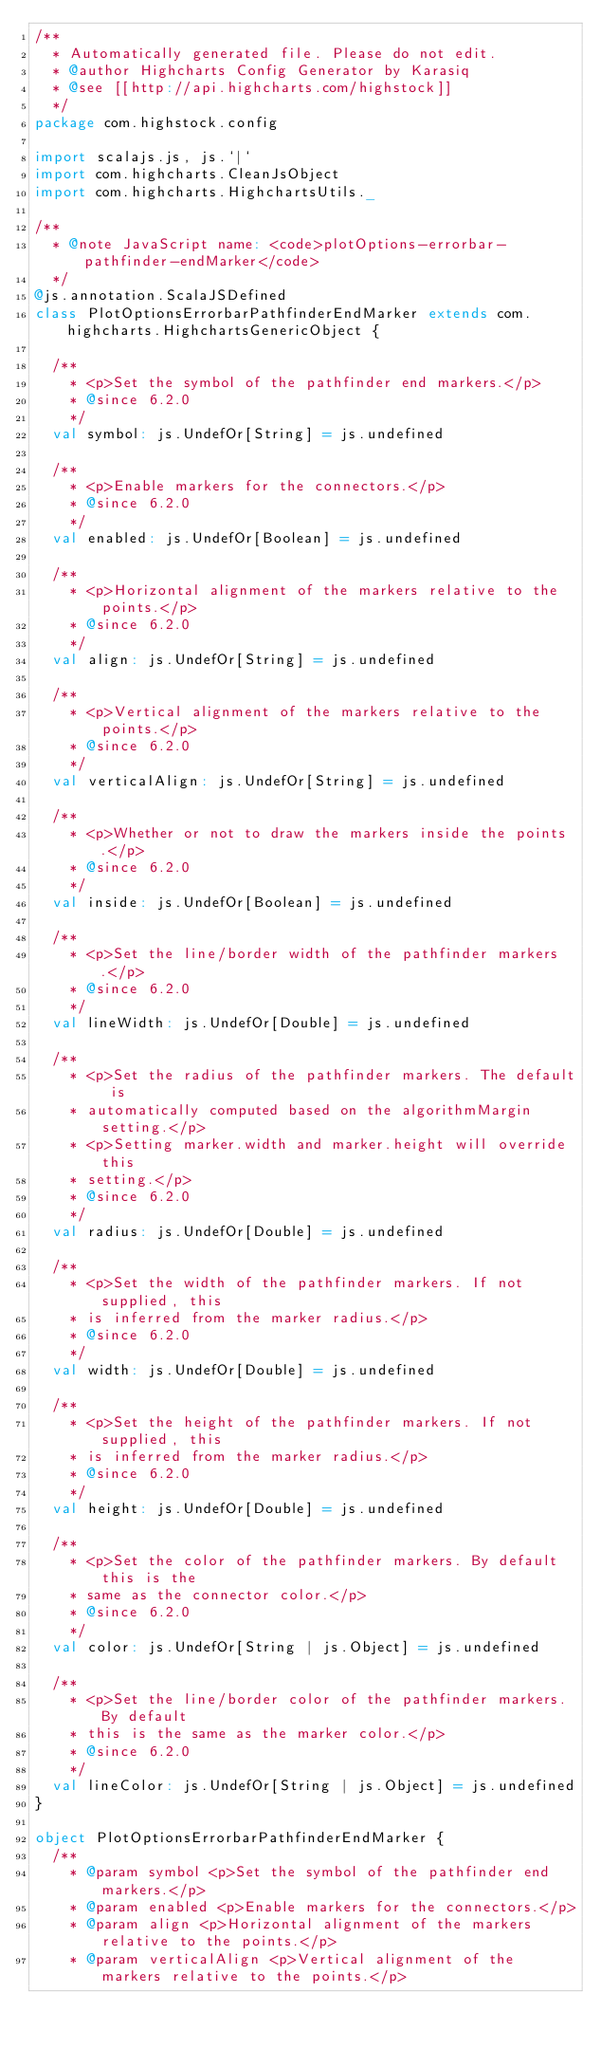Convert code to text. <code><loc_0><loc_0><loc_500><loc_500><_Scala_>/**
  * Automatically generated file. Please do not edit.
  * @author Highcharts Config Generator by Karasiq
  * @see [[http://api.highcharts.com/highstock]]
  */
package com.highstock.config

import scalajs.js, js.`|`
import com.highcharts.CleanJsObject
import com.highcharts.HighchartsUtils._

/**
  * @note JavaScript name: <code>plotOptions-errorbar-pathfinder-endMarker</code>
  */
@js.annotation.ScalaJSDefined
class PlotOptionsErrorbarPathfinderEndMarker extends com.highcharts.HighchartsGenericObject {

  /**
    * <p>Set the symbol of the pathfinder end markers.</p>
    * @since 6.2.0
    */
  val symbol: js.UndefOr[String] = js.undefined

  /**
    * <p>Enable markers for the connectors.</p>
    * @since 6.2.0
    */
  val enabled: js.UndefOr[Boolean] = js.undefined

  /**
    * <p>Horizontal alignment of the markers relative to the points.</p>
    * @since 6.2.0
    */
  val align: js.UndefOr[String] = js.undefined

  /**
    * <p>Vertical alignment of the markers relative to the points.</p>
    * @since 6.2.0
    */
  val verticalAlign: js.UndefOr[String] = js.undefined

  /**
    * <p>Whether or not to draw the markers inside the points.</p>
    * @since 6.2.0
    */
  val inside: js.UndefOr[Boolean] = js.undefined

  /**
    * <p>Set the line/border width of the pathfinder markers.</p>
    * @since 6.2.0
    */
  val lineWidth: js.UndefOr[Double] = js.undefined

  /**
    * <p>Set the radius of the pathfinder markers. The default is
    * automatically computed based on the algorithmMargin setting.</p>
    * <p>Setting marker.width and marker.height will override this
    * setting.</p>
    * @since 6.2.0
    */
  val radius: js.UndefOr[Double] = js.undefined

  /**
    * <p>Set the width of the pathfinder markers. If not supplied, this
    * is inferred from the marker radius.</p>
    * @since 6.2.0
    */
  val width: js.UndefOr[Double] = js.undefined

  /**
    * <p>Set the height of the pathfinder markers. If not supplied, this
    * is inferred from the marker radius.</p>
    * @since 6.2.0
    */
  val height: js.UndefOr[Double] = js.undefined

  /**
    * <p>Set the color of the pathfinder markers. By default this is the
    * same as the connector color.</p>
    * @since 6.2.0
    */
  val color: js.UndefOr[String | js.Object] = js.undefined

  /**
    * <p>Set the line/border color of the pathfinder markers. By default
    * this is the same as the marker color.</p>
    * @since 6.2.0
    */
  val lineColor: js.UndefOr[String | js.Object] = js.undefined
}

object PlotOptionsErrorbarPathfinderEndMarker {
  /**
    * @param symbol <p>Set the symbol of the pathfinder end markers.</p>
    * @param enabled <p>Enable markers for the connectors.</p>
    * @param align <p>Horizontal alignment of the markers relative to the points.</p>
    * @param verticalAlign <p>Vertical alignment of the markers relative to the points.</p></code> 